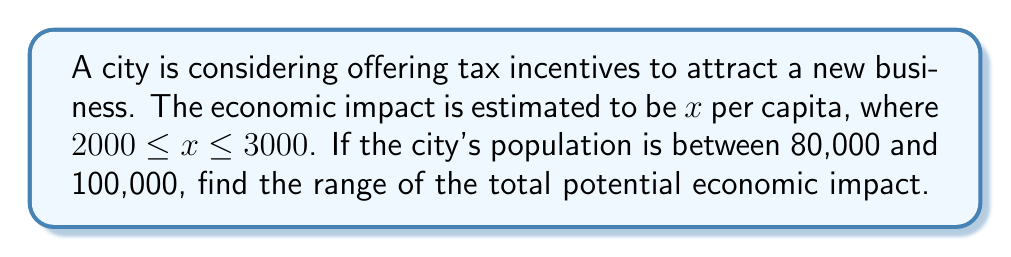Give your solution to this math problem. To solve this problem, we need to consider the minimum and maximum possible impacts:

1. Minimum impact:
   - Lowest per capita impact: $\$2000$
   - Lowest population: $80,000$
   - Minimum total impact: $\$2000 \times 80,000 = \$160,000,000$

2. Maximum impact:
   - Highest per capita impact: $\$3000$
   - Highest population: $100,000$
   - Maximum total impact: $\$3000 \times 100,000 = \$300,000,000$

Therefore, we can express the total economic impact $E$ as:

$$160,000,000 \leq E \leq 300,000,000$$

This can also be written in interval notation as:

$$E \in [\$160,000,000, \$300,000,000]$$
Answer: The range of the total potential economic impact is $[\$160,000,000, \$300,000,000]$. 